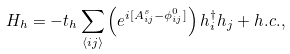Convert formula to latex. <formula><loc_0><loc_0><loc_500><loc_500>H _ { h } = - t _ { h } \sum _ { \langle i j \rangle } \left ( e ^ { i [ A _ { i j } ^ { s } - \phi _ { i j } ^ { 0 } ] } \right ) h _ { i } ^ { \dagger } h _ { j } + h . c . ,</formula> 